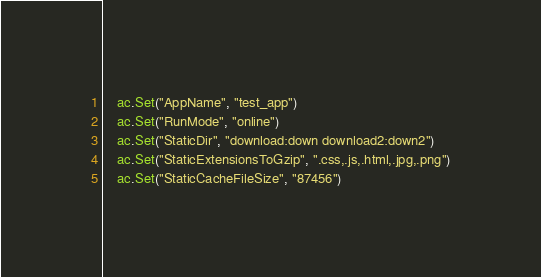<code> <loc_0><loc_0><loc_500><loc_500><_Go_>	ac.Set("AppName", "test_app")
	ac.Set("RunMode", "online")
	ac.Set("StaticDir", "download:down download2:down2")
	ac.Set("StaticExtensionsToGzip", ".css,.js,.html,.jpg,.png")
	ac.Set("StaticCacheFileSize", "87456")</code> 